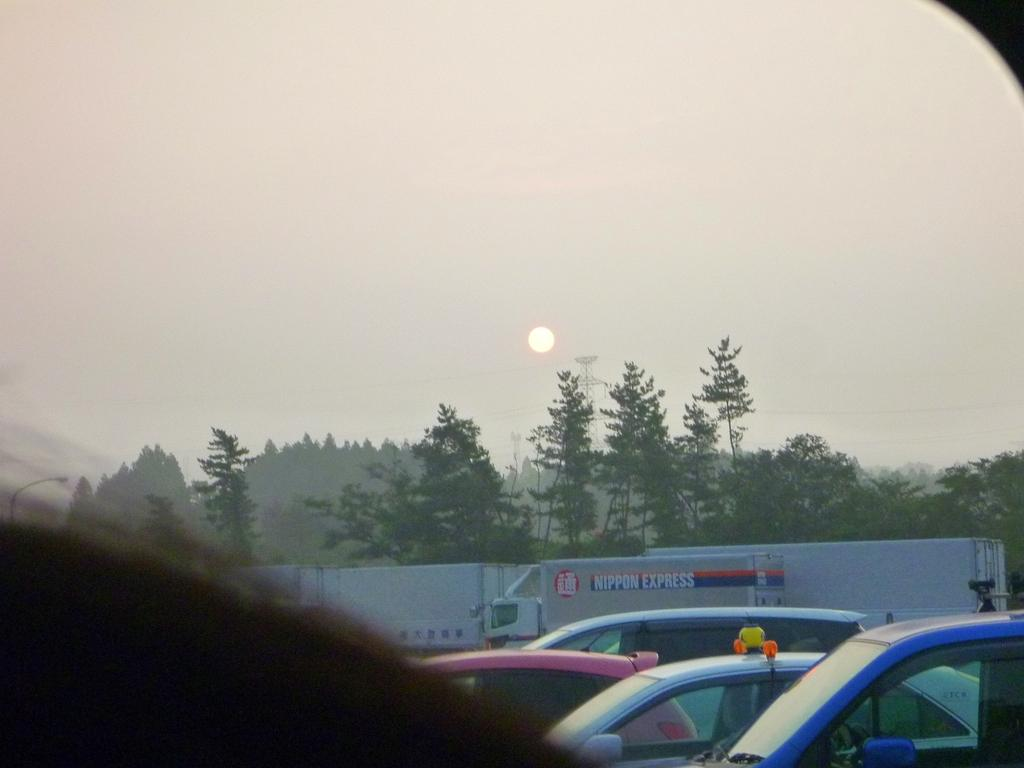What types of objects can be seen in the image? There are vehicles and trees visible in the image. What structure can be seen in the background of the image? There is a tower visible in the background of the image. What celestial body is observable in the sky? The sun is observable in the sky. What part of the natural environment is visible in the image? The sky is visible in the background of the image. What type of roof can be seen on the tank in the image? There is no tank present in the image, so there is no roof to be seen on it. 